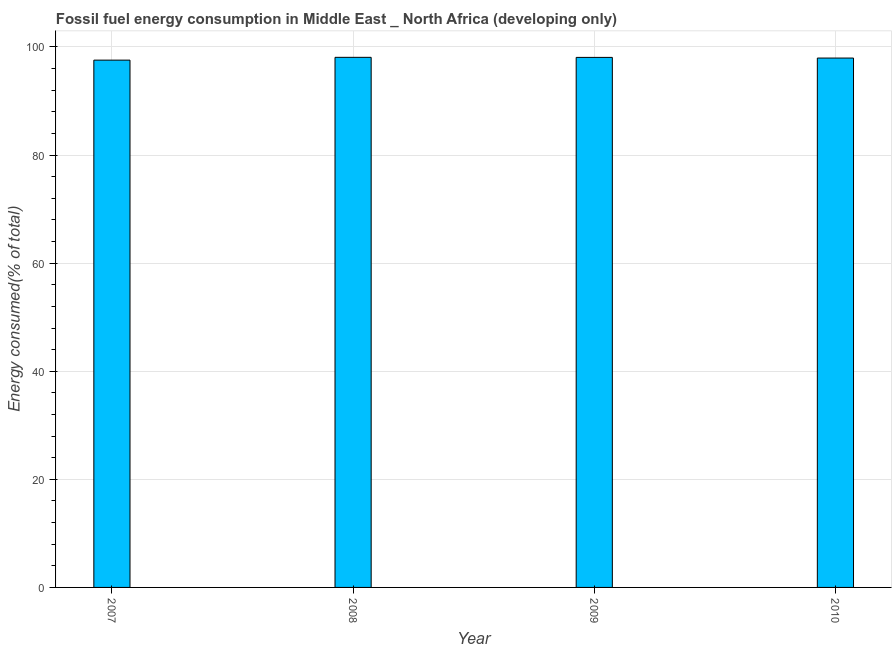Does the graph contain any zero values?
Offer a very short reply. No. Does the graph contain grids?
Ensure brevity in your answer.  Yes. What is the title of the graph?
Your answer should be compact. Fossil fuel energy consumption in Middle East _ North Africa (developing only). What is the label or title of the Y-axis?
Give a very brief answer. Energy consumed(% of total). What is the fossil fuel energy consumption in 2008?
Keep it short and to the point. 98.08. Across all years, what is the maximum fossil fuel energy consumption?
Your answer should be very brief. 98.08. Across all years, what is the minimum fossil fuel energy consumption?
Offer a very short reply. 97.56. What is the sum of the fossil fuel energy consumption?
Give a very brief answer. 391.67. What is the difference between the fossil fuel energy consumption in 2007 and 2010?
Provide a succinct answer. -0.39. What is the average fossil fuel energy consumption per year?
Ensure brevity in your answer.  97.92. What is the median fossil fuel energy consumption?
Offer a terse response. 98.01. What is the ratio of the fossil fuel energy consumption in 2007 to that in 2009?
Keep it short and to the point. 0.99. Is the difference between the fossil fuel energy consumption in 2007 and 2008 greater than the difference between any two years?
Offer a very short reply. Yes. What is the difference between the highest and the second highest fossil fuel energy consumption?
Keep it short and to the point. 0.01. Is the sum of the fossil fuel energy consumption in 2007 and 2008 greater than the maximum fossil fuel energy consumption across all years?
Keep it short and to the point. Yes. What is the difference between the highest and the lowest fossil fuel energy consumption?
Provide a short and direct response. 0.52. In how many years, is the fossil fuel energy consumption greater than the average fossil fuel energy consumption taken over all years?
Your answer should be very brief. 3. How many bars are there?
Your answer should be compact. 4. Are all the bars in the graph horizontal?
Ensure brevity in your answer.  No. What is the difference between two consecutive major ticks on the Y-axis?
Ensure brevity in your answer.  20. Are the values on the major ticks of Y-axis written in scientific E-notation?
Offer a very short reply. No. What is the Energy consumed(% of total) in 2007?
Offer a terse response. 97.56. What is the Energy consumed(% of total) in 2008?
Give a very brief answer. 98.08. What is the Energy consumed(% of total) in 2009?
Keep it short and to the point. 98.07. What is the Energy consumed(% of total) of 2010?
Give a very brief answer. 97.95. What is the difference between the Energy consumed(% of total) in 2007 and 2008?
Keep it short and to the point. -0.52. What is the difference between the Energy consumed(% of total) in 2007 and 2009?
Offer a very short reply. -0.51. What is the difference between the Energy consumed(% of total) in 2007 and 2010?
Your response must be concise. -0.38. What is the difference between the Energy consumed(% of total) in 2008 and 2009?
Your answer should be very brief. 0.01. What is the difference between the Energy consumed(% of total) in 2008 and 2010?
Provide a short and direct response. 0.13. What is the difference between the Energy consumed(% of total) in 2009 and 2010?
Provide a short and direct response. 0.12. What is the ratio of the Energy consumed(% of total) in 2007 to that in 2008?
Give a very brief answer. 0.99. What is the ratio of the Energy consumed(% of total) in 2008 to that in 2010?
Your answer should be compact. 1. 